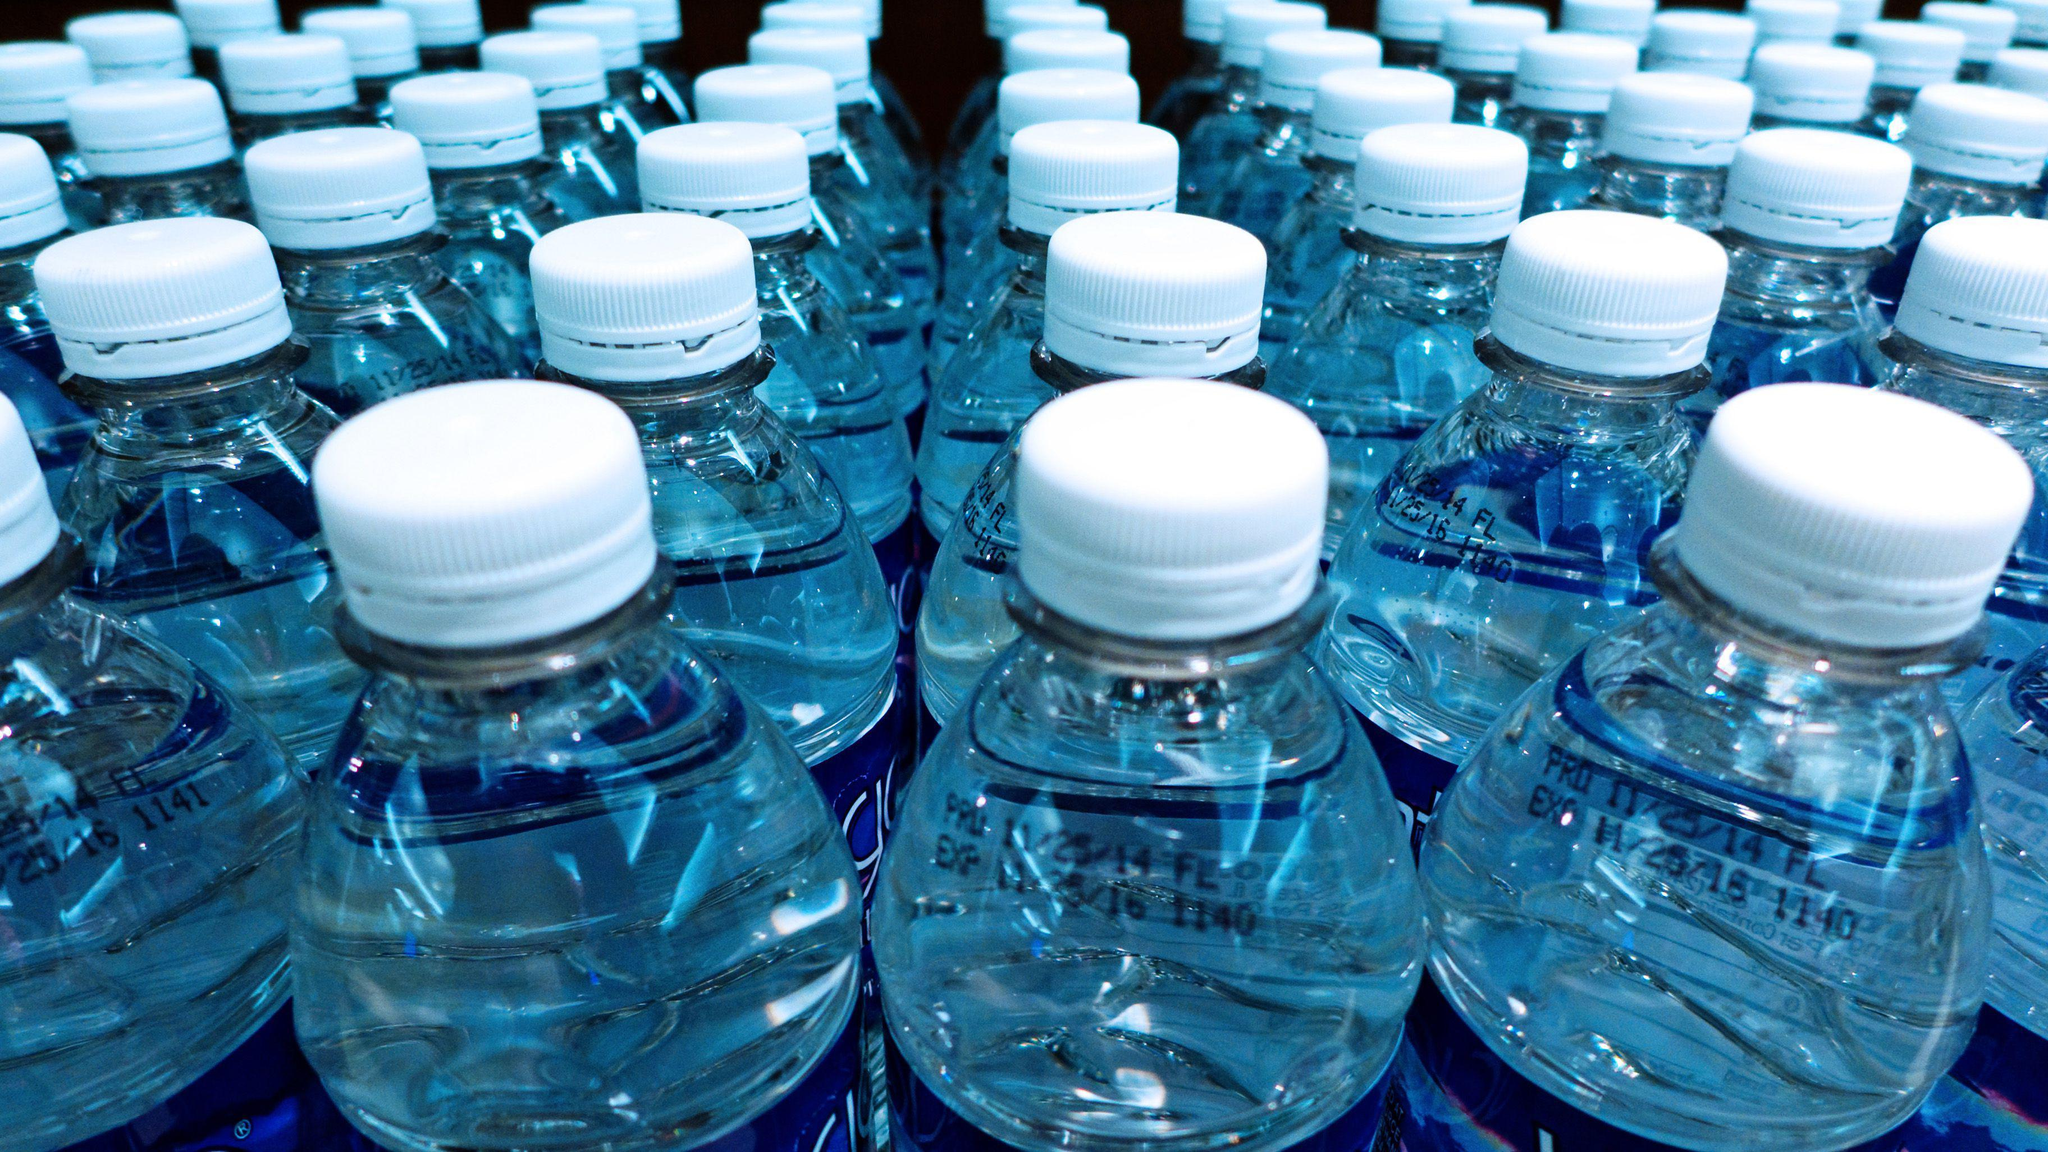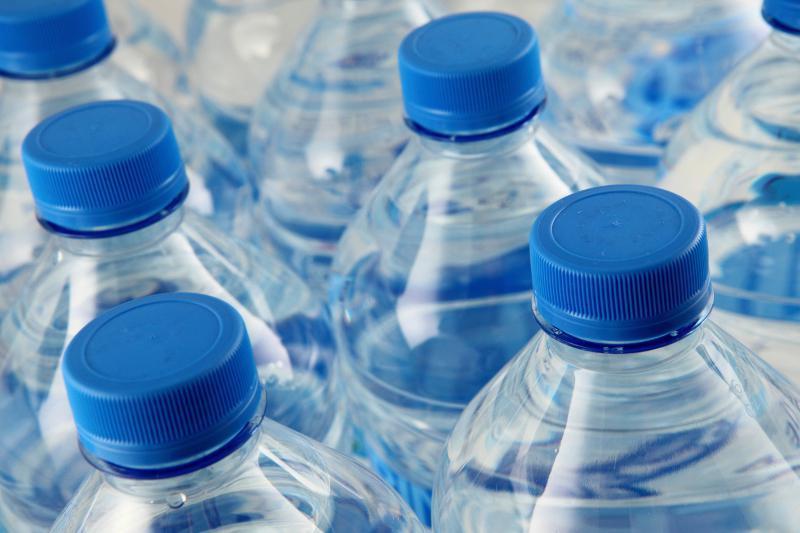The first image is the image on the left, the second image is the image on the right. Examine the images to the left and right. Is the description "Large blue bottles in one image have clear caps and a side hand grip." accurate? Answer yes or no. No. The first image is the image on the left, the second image is the image on the right. For the images shown, is this caption "An image shows at least one water bottle with a loop handle on the lid." true? Answer yes or no. No. 